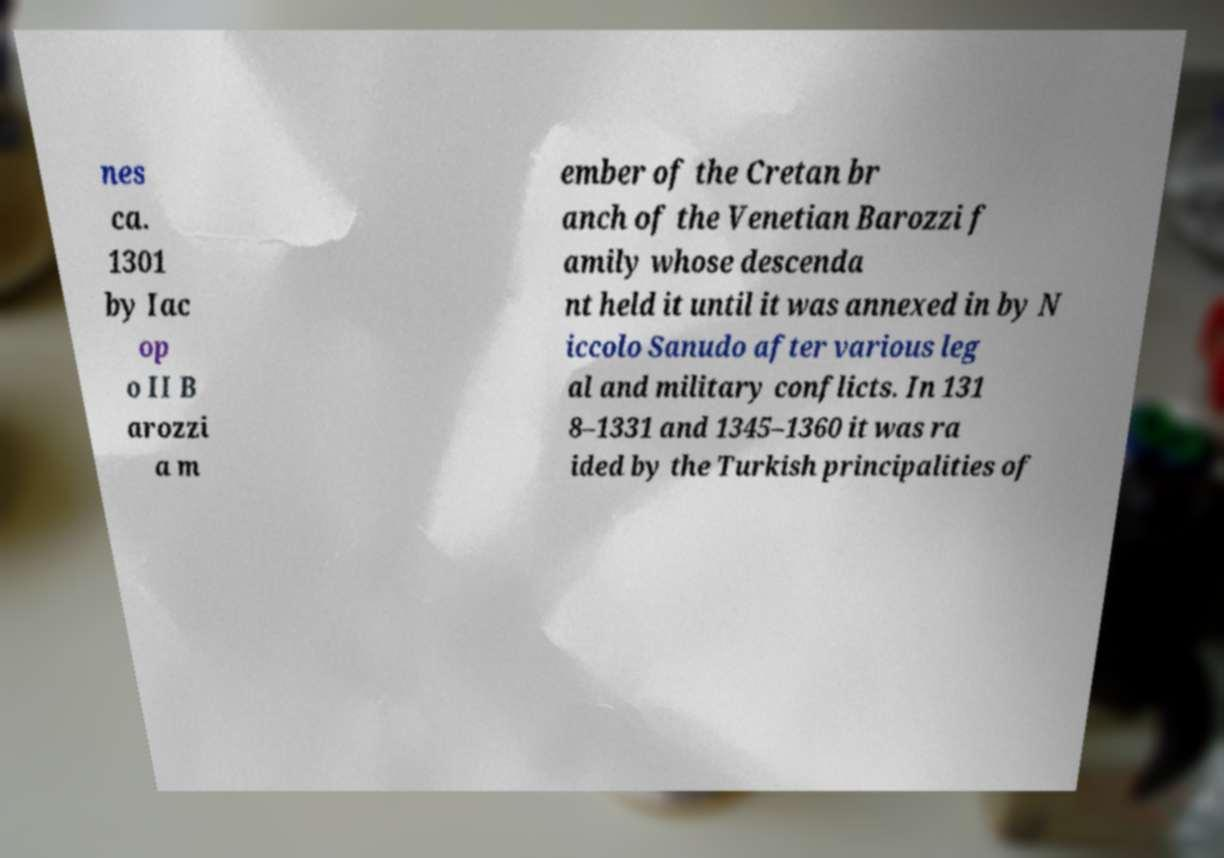Can you read and provide the text displayed in the image?This photo seems to have some interesting text. Can you extract and type it out for me? nes ca. 1301 by Iac op o II B arozzi a m ember of the Cretan br anch of the Venetian Barozzi f amily whose descenda nt held it until it was annexed in by N iccolo Sanudo after various leg al and military conflicts. In 131 8–1331 and 1345–1360 it was ra ided by the Turkish principalities of 